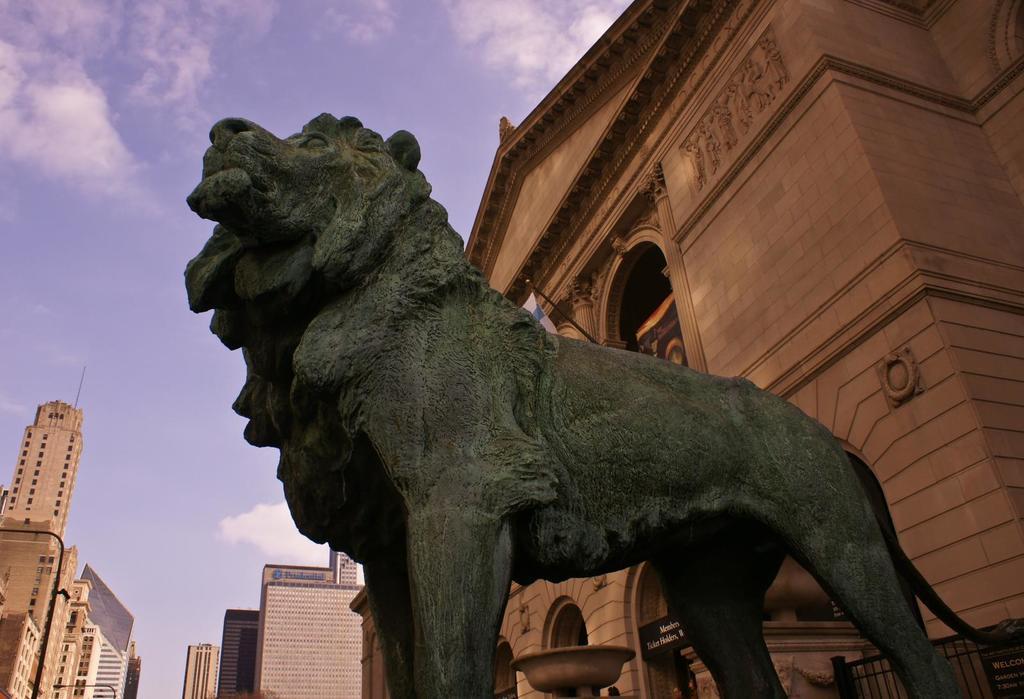Can you describe this image briefly? Here we can see animal statue. Background we can see buildings,fence and sky is cloudy. 